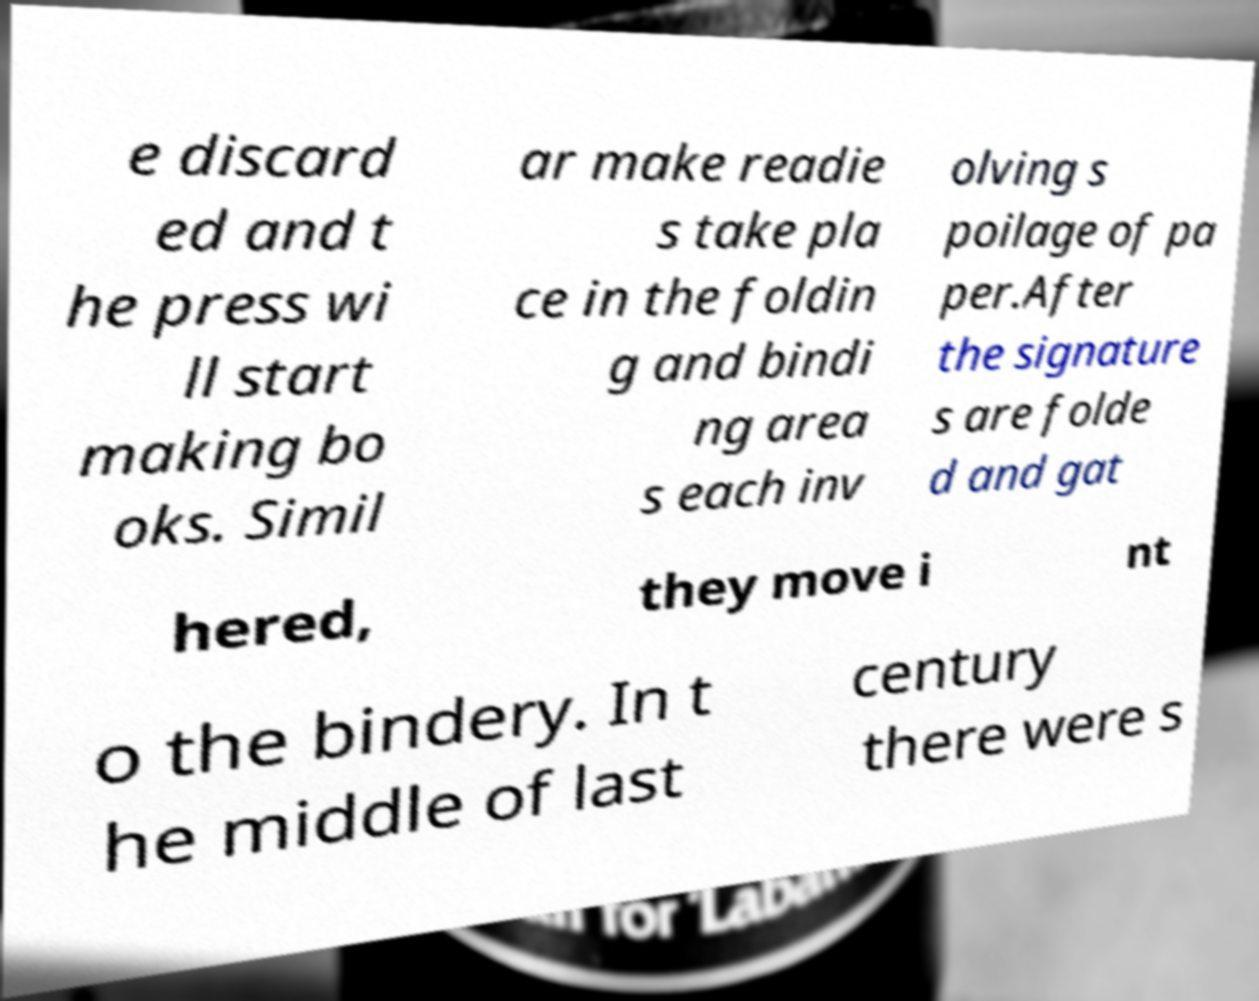Can you read and provide the text displayed in the image?This photo seems to have some interesting text. Can you extract and type it out for me? e discard ed and t he press wi ll start making bo oks. Simil ar make readie s take pla ce in the foldin g and bindi ng area s each inv olving s poilage of pa per.After the signature s are folde d and gat hered, they move i nt o the bindery. In t he middle of last century there were s 